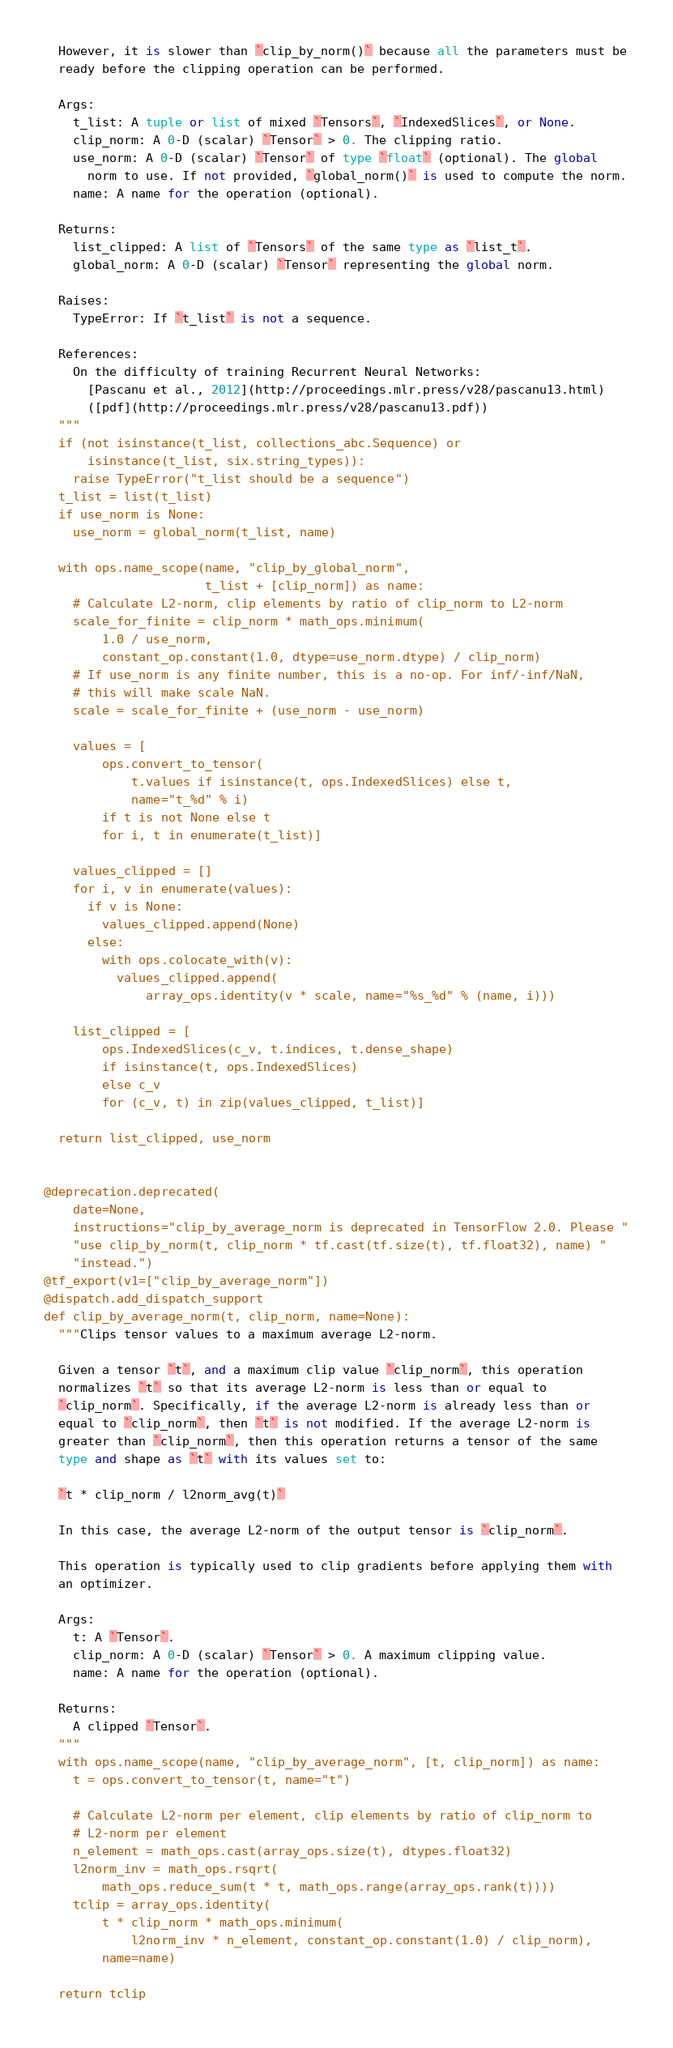<code> <loc_0><loc_0><loc_500><loc_500><_Python_>  However, it is slower than `clip_by_norm()` because all the parameters must be
  ready before the clipping operation can be performed.

  Args:
    t_list: A tuple or list of mixed `Tensors`, `IndexedSlices`, or None.
    clip_norm: A 0-D (scalar) `Tensor` > 0. The clipping ratio.
    use_norm: A 0-D (scalar) `Tensor` of type `float` (optional). The global
      norm to use. If not provided, `global_norm()` is used to compute the norm.
    name: A name for the operation (optional).

  Returns:
    list_clipped: A list of `Tensors` of the same type as `list_t`.
    global_norm: A 0-D (scalar) `Tensor` representing the global norm.

  Raises:
    TypeError: If `t_list` is not a sequence.

  References:
    On the difficulty of training Recurrent Neural Networks:
      [Pascanu et al., 2012](http://proceedings.mlr.press/v28/pascanu13.html)
      ([pdf](http://proceedings.mlr.press/v28/pascanu13.pdf))
  """
  if (not isinstance(t_list, collections_abc.Sequence) or
      isinstance(t_list, six.string_types)):
    raise TypeError("t_list should be a sequence")
  t_list = list(t_list)
  if use_norm is None:
    use_norm = global_norm(t_list, name)

  with ops.name_scope(name, "clip_by_global_norm",
                      t_list + [clip_norm]) as name:
    # Calculate L2-norm, clip elements by ratio of clip_norm to L2-norm
    scale_for_finite = clip_norm * math_ops.minimum(
        1.0 / use_norm,
        constant_op.constant(1.0, dtype=use_norm.dtype) / clip_norm)
    # If use_norm is any finite number, this is a no-op. For inf/-inf/NaN,
    # this will make scale NaN.
    scale = scale_for_finite + (use_norm - use_norm)

    values = [
        ops.convert_to_tensor(
            t.values if isinstance(t, ops.IndexedSlices) else t,
            name="t_%d" % i)
        if t is not None else t
        for i, t in enumerate(t_list)]

    values_clipped = []
    for i, v in enumerate(values):
      if v is None:
        values_clipped.append(None)
      else:
        with ops.colocate_with(v):
          values_clipped.append(
              array_ops.identity(v * scale, name="%s_%d" % (name, i)))

    list_clipped = [
        ops.IndexedSlices(c_v, t.indices, t.dense_shape)
        if isinstance(t, ops.IndexedSlices)
        else c_v
        for (c_v, t) in zip(values_clipped, t_list)]

  return list_clipped, use_norm


@deprecation.deprecated(
    date=None,
    instructions="clip_by_average_norm is deprecated in TensorFlow 2.0. Please "
    "use clip_by_norm(t, clip_norm * tf.cast(tf.size(t), tf.float32), name) "
    "instead.")
@tf_export(v1=["clip_by_average_norm"])
@dispatch.add_dispatch_support
def clip_by_average_norm(t, clip_norm, name=None):
  """Clips tensor values to a maximum average L2-norm.

  Given a tensor `t`, and a maximum clip value `clip_norm`, this operation
  normalizes `t` so that its average L2-norm is less than or equal to
  `clip_norm`. Specifically, if the average L2-norm is already less than or
  equal to `clip_norm`, then `t` is not modified. If the average L2-norm is
  greater than `clip_norm`, then this operation returns a tensor of the same
  type and shape as `t` with its values set to:

  `t * clip_norm / l2norm_avg(t)`

  In this case, the average L2-norm of the output tensor is `clip_norm`.

  This operation is typically used to clip gradients before applying them with
  an optimizer.

  Args:
    t: A `Tensor`.
    clip_norm: A 0-D (scalar) `Tensor` > 0. A maximum clipping value.
    name: A name for the operation (optional).

  Returns:
    A clipped `Tensor`.
  """
  with ops.name_scope(name, "clip_by_average_norm", [t, clip_norm]) as name:
    t = ops.convert_to_tensor(t, name="t")

    # Calculate L2-norm per element, clip elements by ratio of clip_norm to
    # L2-norm per element
    n_element = math_ops.cast(array_ops.size(t), dtypes.float32)
    l2norm_inv = math_ops.rsqrt(
        math_ops.reduce_sum(t * t, math_ops.range(array_ops.rank(t))))
    tclip = array_ops.identity(
        t * clip_norm * math_ops.minimum(
            l2norm_inv * n_element, constant_op.constant(1.0) / clip_norm),
        name=name)

  return tclip
</code> 